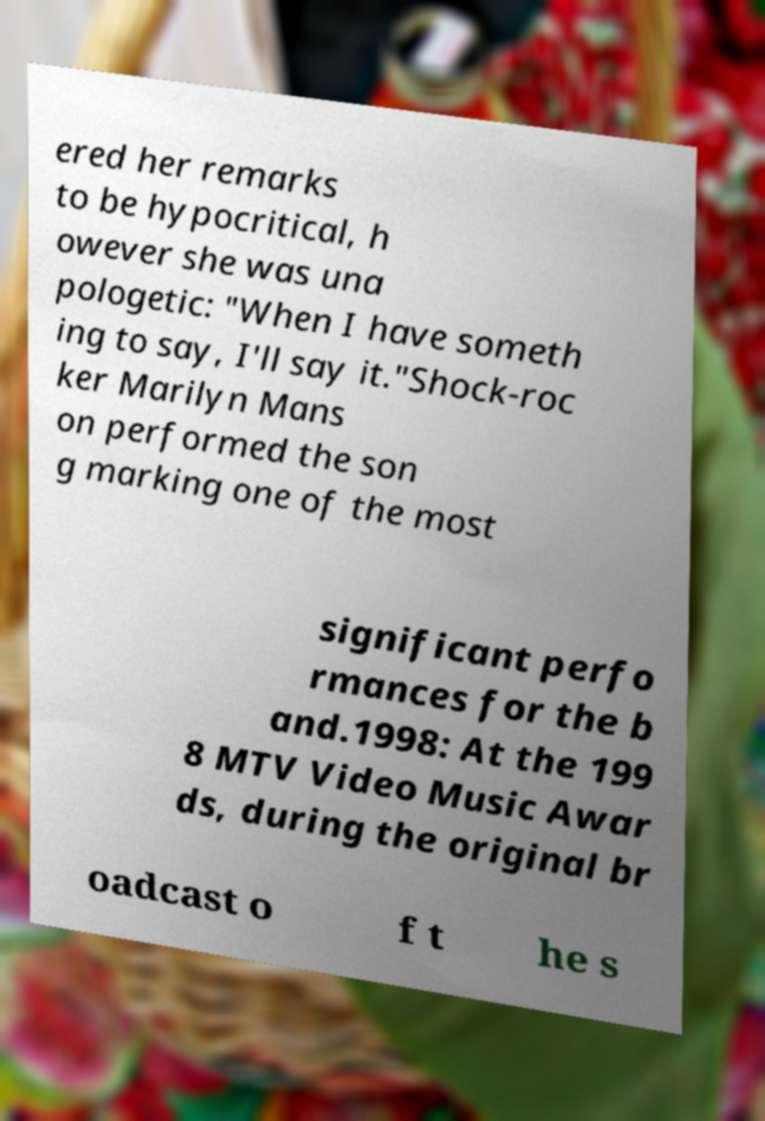Please identify and transcribe the text found in this image. ered her remarks to be hypocritical, h owever she was una pologetic: "When I have someth ing to say, I'll say it."Shock-roc ker Marilyn Mans on performed the son g marking one of the most significant perfo rmances for the b and.1998: At the 199 8 MTV Video Music Awar ds, during the original br oadcast o f t he s 